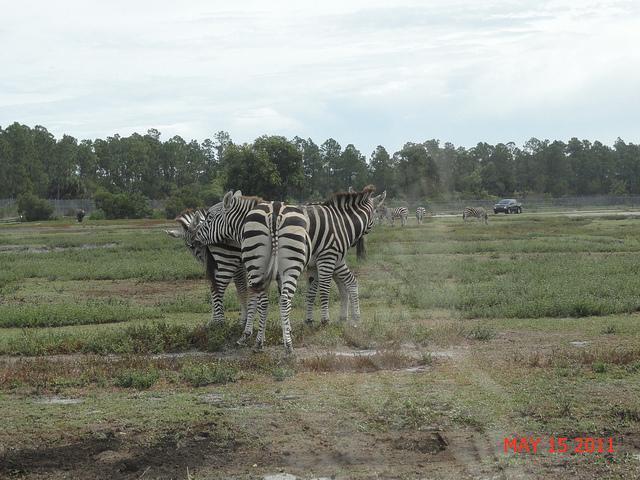What animal is most similar to these?
Pick the right solution, then justify: 'Answer: answer
Rationale: rationale.'
Options: Horse, echidna, leopard, sugar glider. Answer: horse.
Rationale: The animal looks like a horse. 